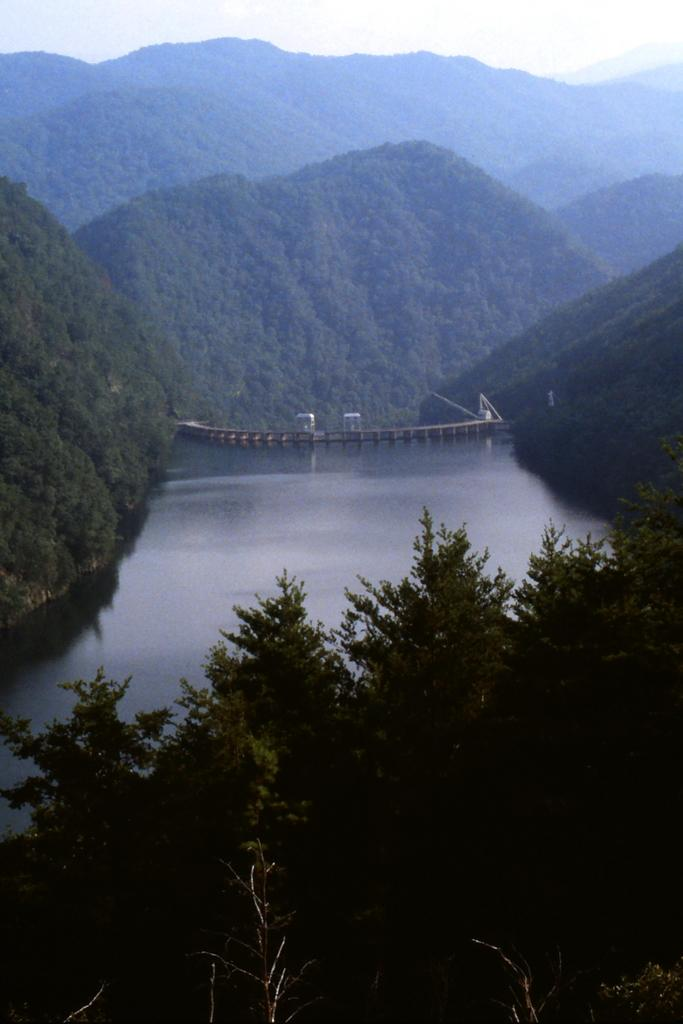What is located in the center of the image? There is water and a bridge in the center of the image. What type of structure is present in the water? There is a bridge in the center of the image. What can be seen around the area of the image? Trees are present around the area of the image. What type of skin condition is visible on the bridge in the image? There is no skin condition present in the image, as the bridge is a structure and not a living organism. How much money is being exchanged on the bridge in the image? There is no indication of any money exchange in the image, as it primarily features a bridge and water. 